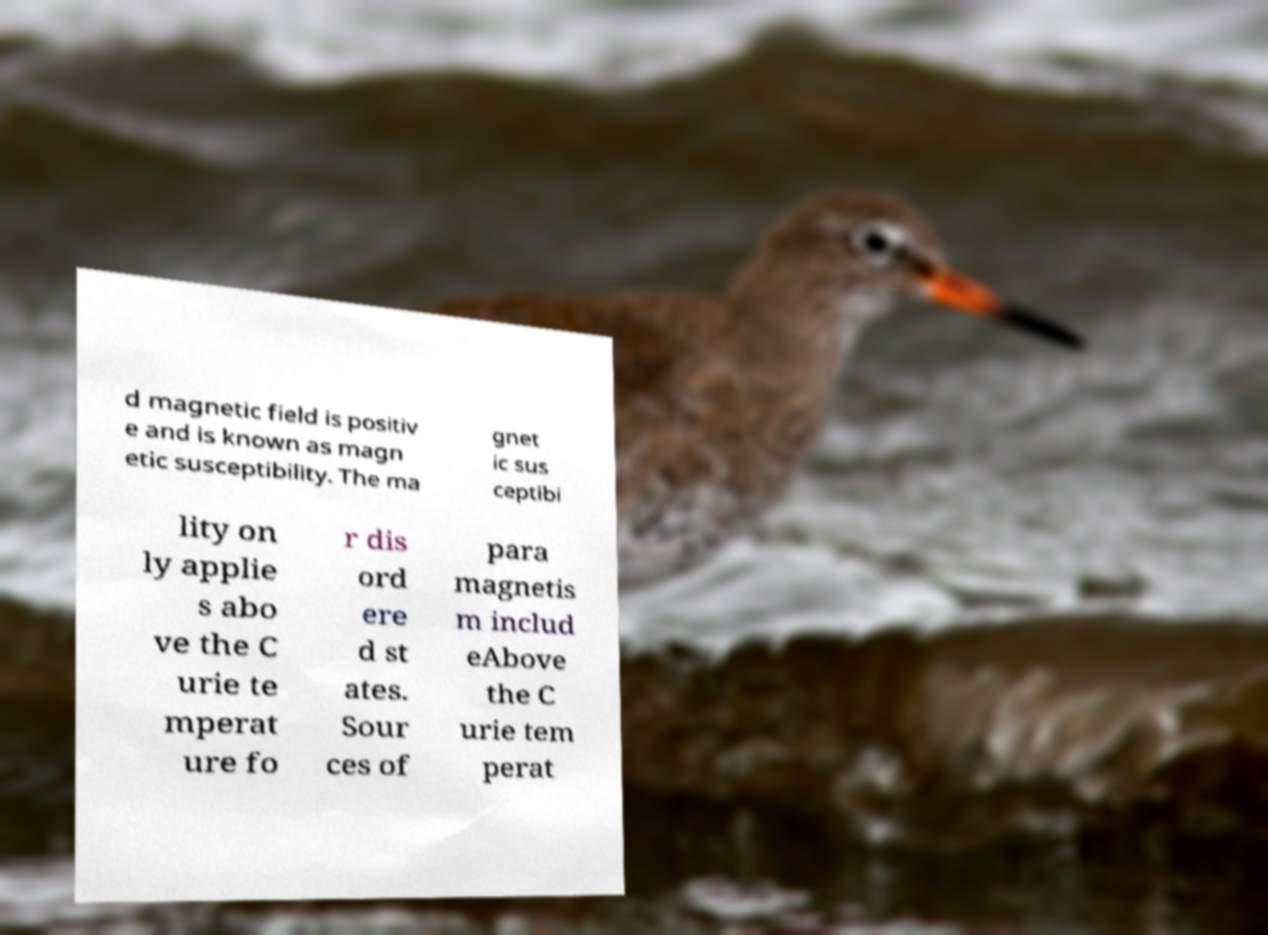For documentation purposes, I need the text within this image transcribed. Could you provide that? d magnetic field is positiv e and is known as magn etic susceptibility. The ma gnet ic sus ceptibi lity on ly applie s abo ve the C urie te mperat ure fo r dis ord ere d st ates. Sour ces of para magnetis m includ eAbove the C urie tem perat 